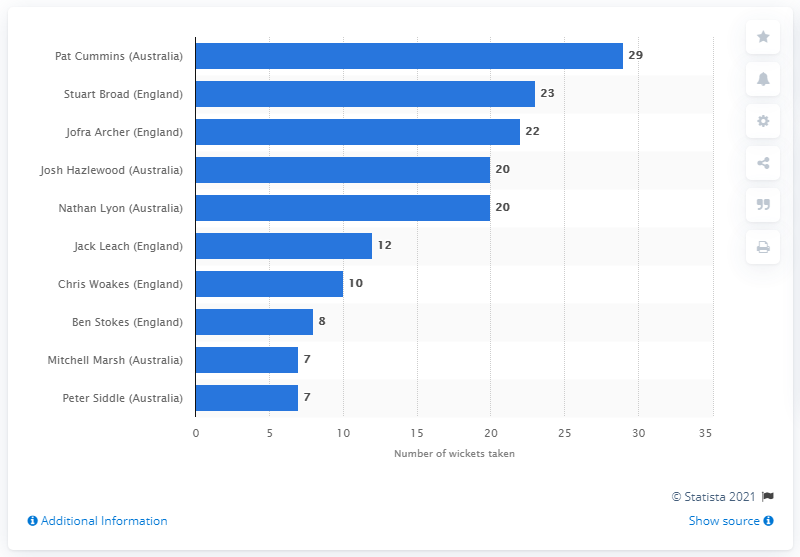Outline some significant characteristics in this image. Pat Cummins took 29 wickets during the 2019 Ashes series, which was an impressive feat. 